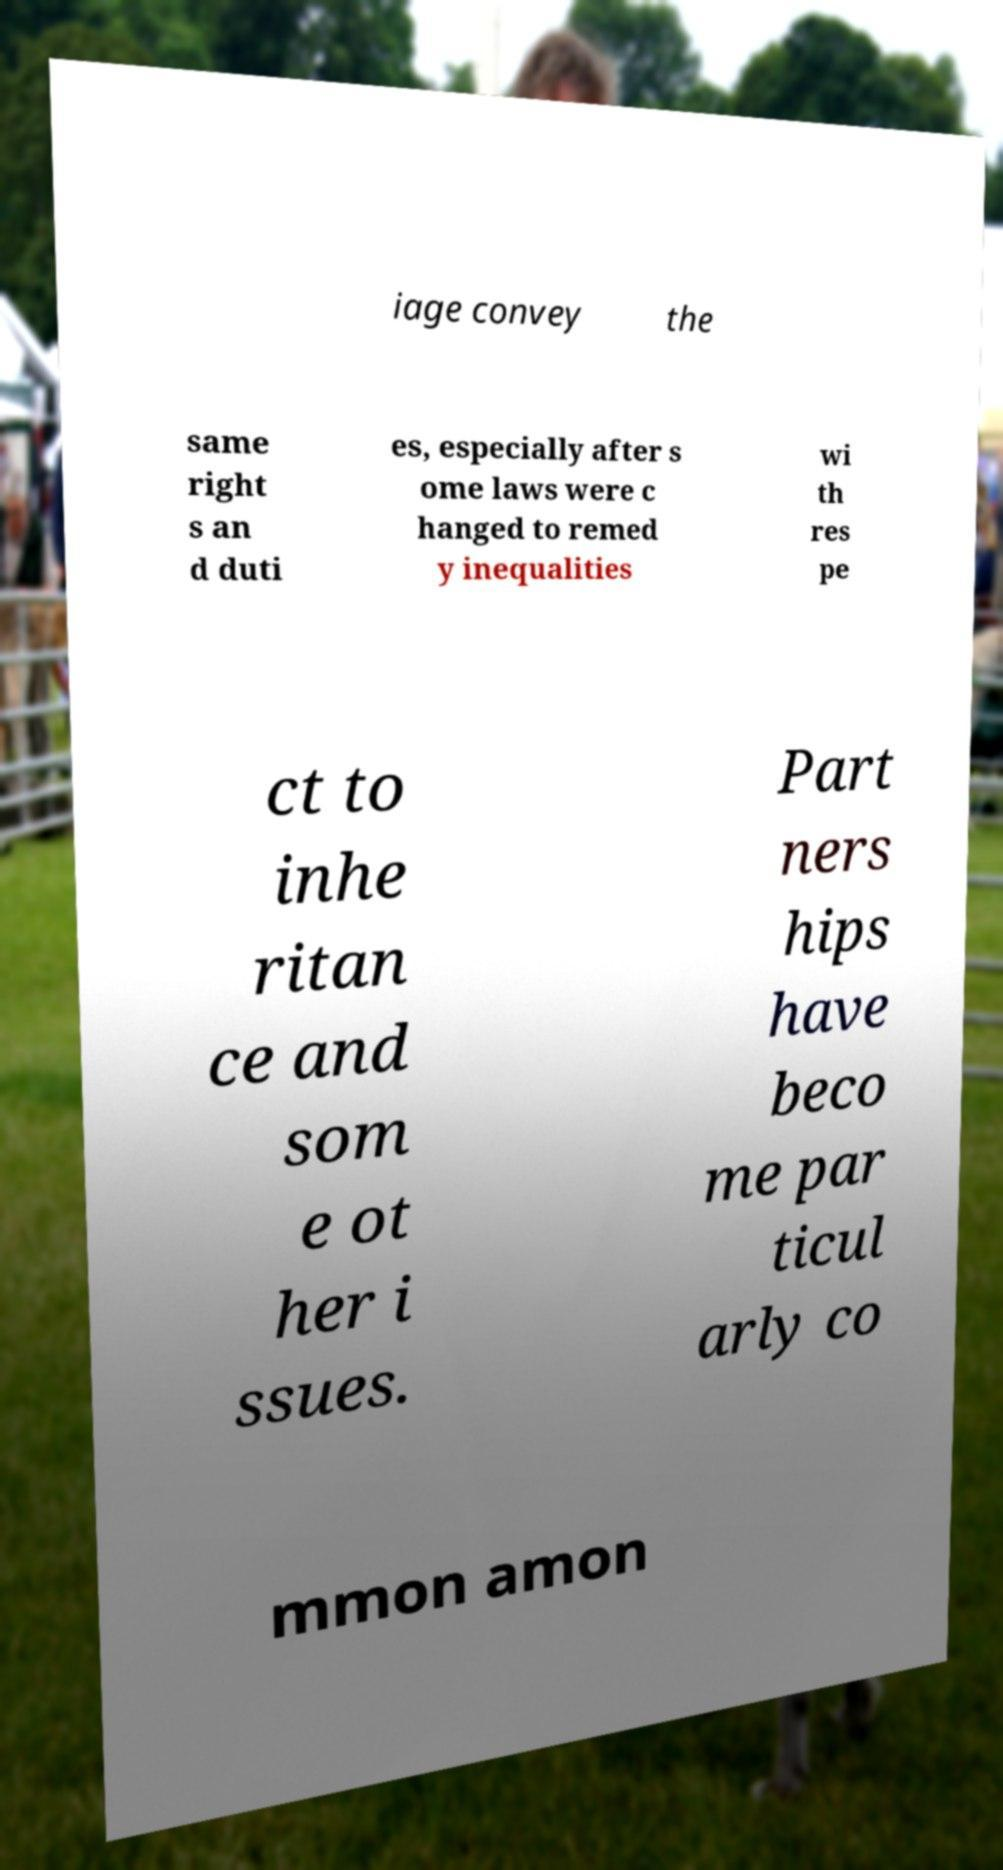Please read and relay the text visible in this image. What does it say? iage convey the same right s an d duti es, especially after s ome laws were c hanged to remed y inequalities wi th res pe ct to inhe ritan ce and som e ot her i ssues. Part ners hips have beco me par ticul arly co mmon amon 